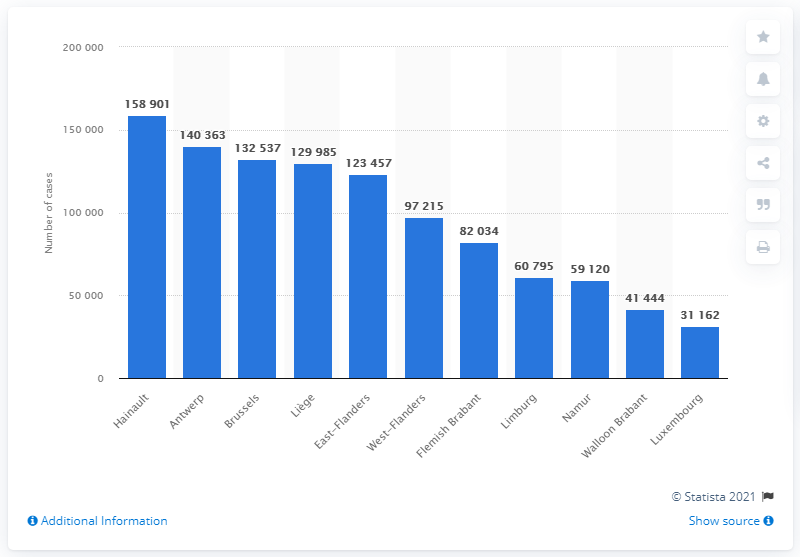Identify some key points in this picture. Antwerp was the second most affected province in Belgium. Hainault was the province with the highest number of COVID-19 cases in the country. 